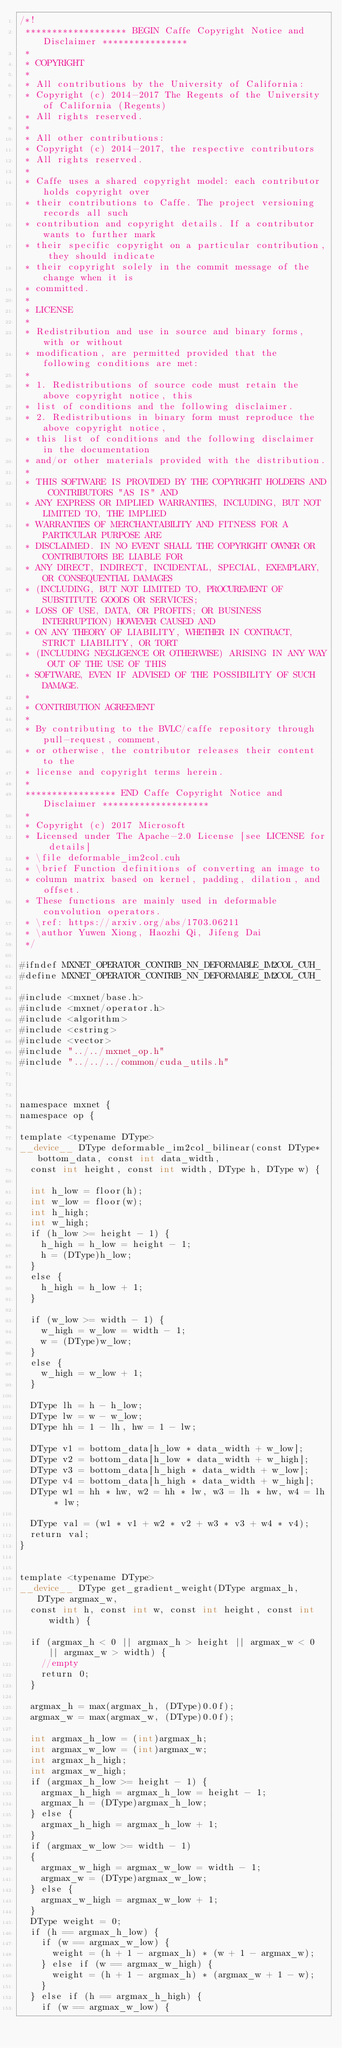Convert code to text. <code><loc_0><loc_0><loc_500><loc_500><_Cuda_>/*!
 ******************* BEGIN Caffe Copyright Notice and Disclaimer ****************
 *
 * COPYRIGHT
 *
 * All contributions by the University of California:
 * Copyright (c) 2014-2017 The Regents of the University of California (Regents)
 * All rights reserved.
 *
 * All other contributions:
 * Copyright (c) 2014-2017, the respective contributors
 * All rights reserved.
 *
 * Caffe uses a shared copyright model: each contributor holds copyright over
 * their contributions to Caffe. The project versioning records all such
 * contribution and copyright details. If a contributor wants to further mark
 * their specific copyright on a particular contribution, they should indicate
 * their copyright solely in the commit message of the change when it is
 * committed.
 *
 * LICENSE
 *
 * Redistribution and use in source and binary forms, with or without
 * modification, are permitted provided that the following conditions are met:
 *
 * 1. Redistributions of source code must retain the above copyright notice, this
 * list of conditions and the following disclaimer.
 * 2. Redistributions in binary form must reproduce the above copyright notice,
 * this list of conditions and the following disclaimer in the documentation
 * and/or other materials provided with the distribution.
 *
 * THIS SOFTWARE IS PROVIDED BY THE COPYRIGHT HOLDERS AND CONTRIBUTORS "AS IS" AND
 * ANY EXPRESS OR IMPLIED WARRANTIES, INCLUDING, BUT NOT LIMITED TO, THE IMPLIED
 * WARRANTIES OF MERCHANTABILITY AND FITNESS FOR A PARTICULAR PURPOSE ARE
 * DISCLAIMED. IN NO EVENT SHALL THE COPYRIGHT OWNER OR CONTRIBUTORS BE LIABLE FOR
 * ANY DIRECT, INDIRECT, INCIDENTAL, SPECIAL, EXEMPLARY, OR CONSEQUENTIAL DAMAGES
 * (INCLUDING, BUT NOT LIMITED TO, PROCUREMENT OF SUBSTITUTE GOODS OR SERVICES;
 * LOSS OF USE, DATA, OR PROFITS; OR BUSINESS INTERRUPTION) HOWEVER CAUSED AND
 * ON ANY THEORY OF LIABILITY, WHETHER IN CONTRACT, STRICT LIABILITY, OR TORT
 * (INCLUDING NEGLIGENCE OR OTHERWISE) ARISING IN ANY WAY OUT OF THE USE OF THIS
 * SOFTWARE, EVEN IF ADVISED OF THE POSSIBILITY OF SUCH DAMAGE.
 *
 * CONTRIBUTION AGREEMENT
 *
 * By contributing to the BVLC/caffe repository through pull-request, comment,
 * or otherwise, the contributor releases their content to the
 * license and copyright terms herein.
 *
 ***************** END Caffe Copyright Notice and Disclaimer ********************
 *
 * Copyright (c) 2017 Microsoft
 * Licensed under The Apache-2.0 License [see LICENSE for details]
 * \file deformable_im2col.cuh
 * \brief Function definitions of converting an image to
 * column matrix based on kernel, padding, dilation, and offset.
 * These functions are mainly used in deformable convolution operators.
 * \ref: https://arxiv.org/abs/1703.06211
 * \author Yuwen Xiong, Haozhi Qi, Jifeng Dai
 */

#ifndef MXNET_OPERATOR_CONTRIB_NN_DEFORMABLE_IM2COL_CUH_
#define MXNET_OPERATOR_CONTRIB_NN_DEFORMABLE_IM2COL_CUH_

#include <mxnet/base.h>
#include <mxnet/operator.h>
#include <algorithm>
#include <cstring>
#include <vector>
#include "../../mxnet_op.h"
#include "../../../common/cuda_utils.h"



namespace mxnet {
namespace op {

template <typename DType>
__device__ DType deformable_im2col_bilinear(const DType* bottom_data, const int data_width,
  const int height, const int width, DType h, DType w) {

  int h_low = floor(h);
  int w_low = floor(w);
  int h_high;
  int w_high;
  if (h_low >= height - 1) {
    h_high = h_low = height - 1;
    h = (DType)h_low;
  }
  else {
    h_high = h_low + 1;
  }

  if (w_low >= width - 1) {
    w_high = w_low = width - 1;
    w = (DType)w_low;
  }
  else {
    w_high = w_low + 1;
  }

  DType lh = h - h_low;
  DType lw = w - w_low;
  DType hh = 1 - lh, hw = 1 - lw;

  DType v1 = bottom_data[h_low * data_width + w_low];
  DType v2 = bottom_data[h_low * data_width + w_high];
  DType v3 = bottom_data[h_high * data_width + w_low];
  DType v4 = bottom_data[h_high * data_width + w_high];
  DType w1 = hh * hw, w2 = hh * lw, w3 = lh * hw, w4 = lh * lw;

  DType val = (w1 * v1 + w2 * v2 + w3 * v3 + w4 * v4);
  return val;
}


template <typename DType>
__device__ DType get_gradient_weight(DType argmax_h, DType argmax_w,
  const int h, const int w, const int height, const int width) {

  if (argmax_h < 0 || argmax_h > height || argmax_w < 0 || argmax_w > width) {
    //empty
    return 0;
  }

  argmax_h = max(argmax_h, (DType)0.0f);
  argmax_w = max(argmax_w, (DType)0.0f);

  int argmax_h_low = (int)argmax_h;
  int argmax_w_low = (int)argmax_w;
  int argmax_h_high;
  int argmax_w_high;
  if (argmax_h_low >= height - 1) {
    argmax_h_high = argmax_h_low = height - 1;
    argmax_h = (DType)argmax_h_low;
  } else {
    argmax_h_high = argmax_h_low + 1;
  }
  if (argmax_w_low >= width - 1)
  {
    argmax_w_high = argmax_w_low = width - 1;
    argmax_w = (DType)argmax_w_low;
  } else {
    argmax_w_high = argmax_w_low + 1;
  }
  DType weight = 0;
  if (h == argmax_h_low) {
    if (w == argmax_w_low) {
      weight = (h + 1 - argmax_h) * (w + 1 - argmax_w);
    } else if (w == argmax_w_high) {
      weight = (h + 1 - argmax_h) * (argmax_w + 1 - w);
    }
  } else if (h == argmax_h_high) {
    if (w == argmax_w_low) {</code> 